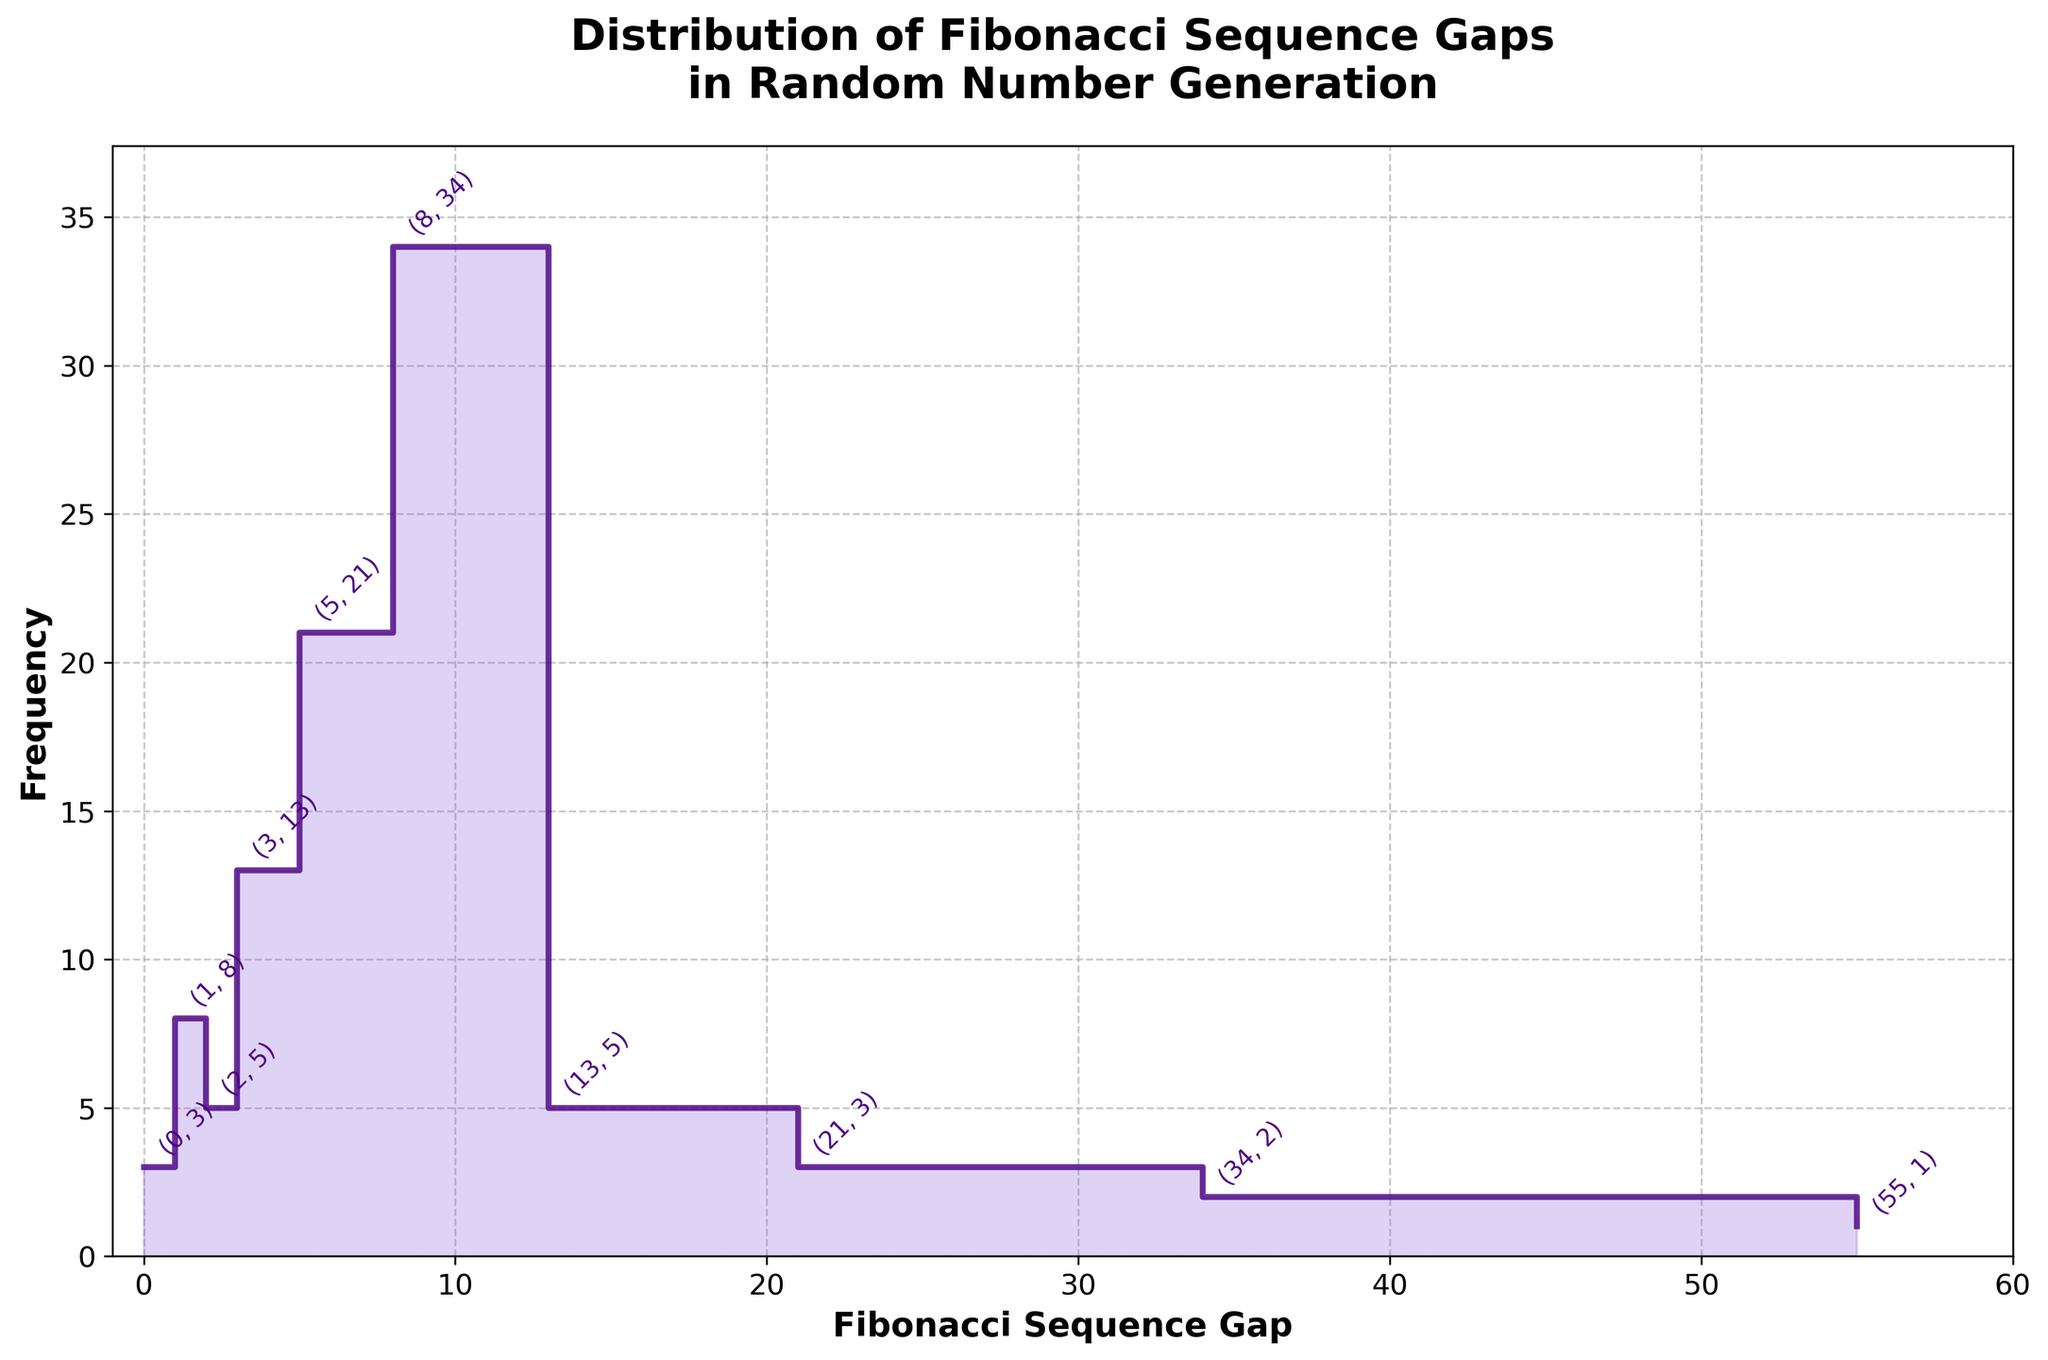What is the title of the figure? The title of the figure is typically found at the top, centered. Here, it is "Distribution of Fibonacci Sequence Gaps in Random Number Generation."
Answer: Distribution of Fibonacci Sequence Gaps in Random Number Generation How many data points are represented on the plot? The x-axis of the plot contains different gaps, and each gap has a corresponding frequency. By counting the number of distinct gaps, we see there are 10 data points.
Answer: 10 What is the frequency of the gap "8"? To find this, locate the gap "8" on the x-axis and follow it vertically to the corresponding point on the step plot. The annotation at this point shows (8, 34).
Answer: 34 What is the highest frequency observed and for which gap? Identify the highest point on the y-axis and then trace horizontally to find the corresponding gap. Here, the highest frequency is 34, corresponding to the gap "8."
Answer: 34, 8 Which gap has a frequency greater than 20 but less than 35? Check the frequency values and identify the gaps falling in this range. From the annotations, the gap "5" has a frequency of 21, fitting the criteria.
Answer: 5 How does the frequency of the gap "13" compare to the gap "21"? Find the annotations for gaps "13" and "21." Gap "13" has a frequency of 5, while gap "21" has a frequency of 3. Comparing these, the frequency of "13" is greater than "21."
Answer: 13 > 21 What is the sum of frequencies for gaps less than 8? Add up the frequencies for gaps "0," "1," "2," "3," and "5." The frequencies are 3, 8, 5, 13, and 21 respectively. Summing these gives 3+8+5+13+21=50.
Answer: 50 Which gap has the second highest frequency? To find the second highest frequency, identify the highest frequency first (34 for gap "8"), then find the next highest. The second highest frequency is 21 for gap "5."
Answer: 5 Is there any gap with a frequency of exactly 2? Check the annotations for any frequency of 2. The annotation for gap "34" shows a frequency of 2.
Answer: 34 What is the range of the y-axis (frequency)? The y-axis range is from the minimum to the maximum frequency observed in the data. The minimum frequency is 0 and the maximum frequency is 34.
Answer: 0 to 34 